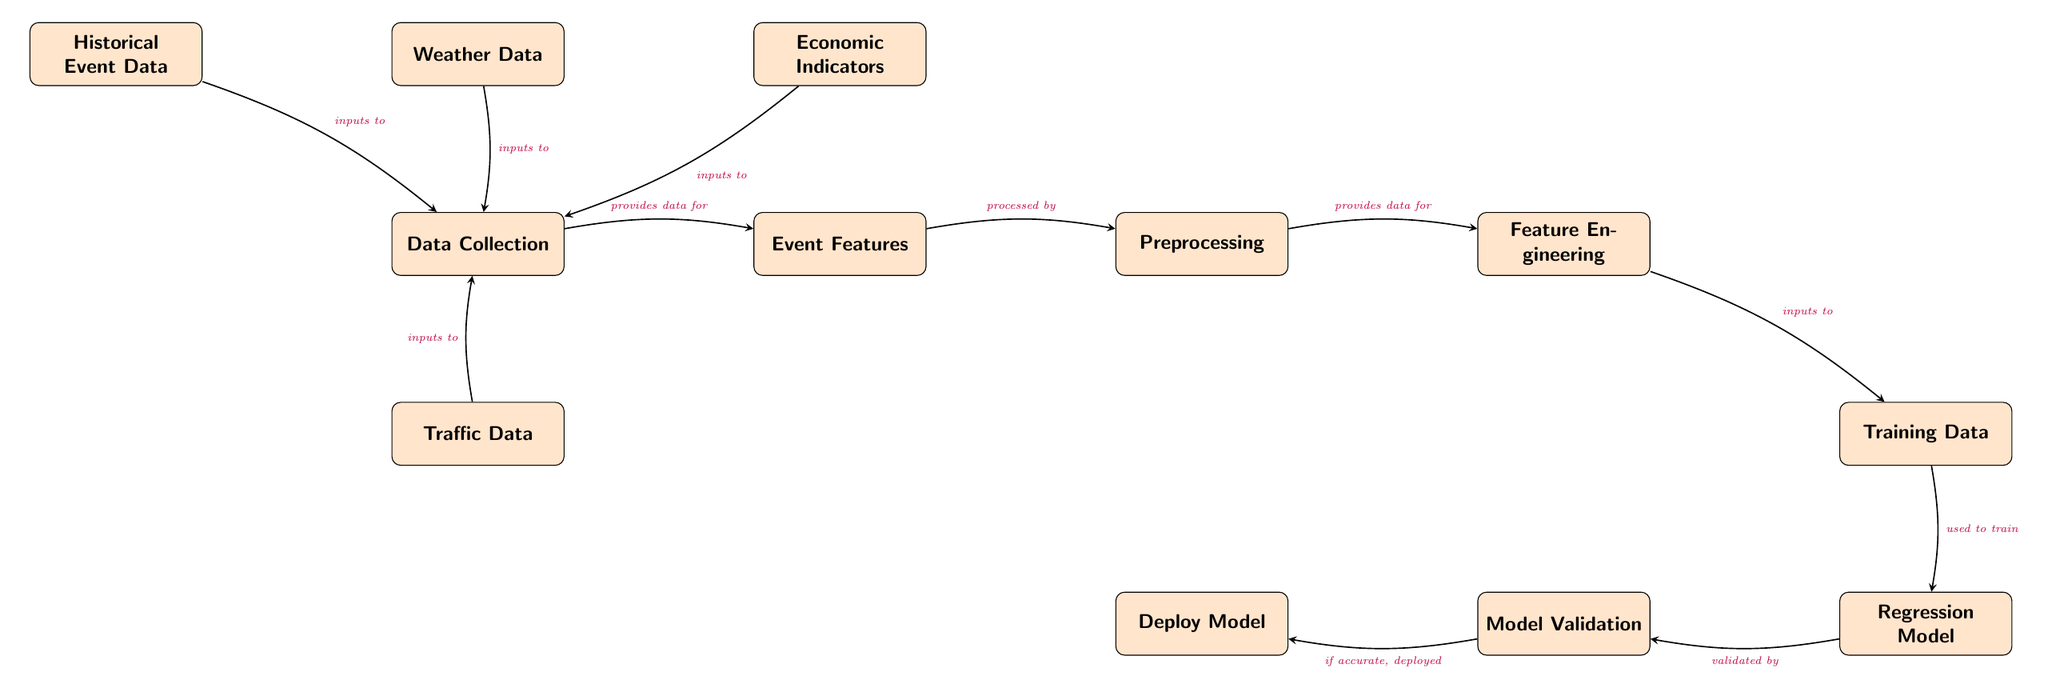What is the first step in the diagram? The first step is represented by the node labeled 'Data Collection', indicating that collecting data is the initial action in the process.
Answer: Data Collection How many input nodes are there that lead to the 'Data Collection' node? There are four input nodes: Historical Event Data, Weather Data, Economic Indicators, and Traffic Data, all feeding into the Data Collection node.
Answer: 4 What type of model is used at the end of the process? The type of model used at the end of the process is a 'Regression Model', which is a common technique in forecasting tasks.
Answer: Regression Model Which node processes the 'Event Features'? The node that processes 'Event Features' is labeled 'Preprocessing', indicating it handles or transforms the event features for further analysis.
Answer: Preprocessing What happens if the model validation is successful? If the model validation is successful, the next step indicated in the diagram is the 'Deploy Model' node, which shows the model is then put into action.
Answer: Deploy Model How does 'Feature Engineering' relate to 'Training Data'? 'Feature Engineering' provides inputs to 'Training Data', meaning that the features derived from engineering influence the data that will be used for the model training.
Answer: Provides inputs to What is the output of the model training process? The output of the model training process is used in the 'Regression Model', which involves applying the trained model to features derived from the training data to make predictions.
Answer: Used to train What is the function of the 'Model Validation' node? The 'Model Validation' node checks if the model's predictions are accurate, which is a critical step before deploying the model into practical use.
Answer: Checks accuracy What is the last component in the diagram? The last component in the diagram is the 'Deploy Model' node, which indicates the final step of putting the model into practice after successful validation.
Answer: Deploy Model 